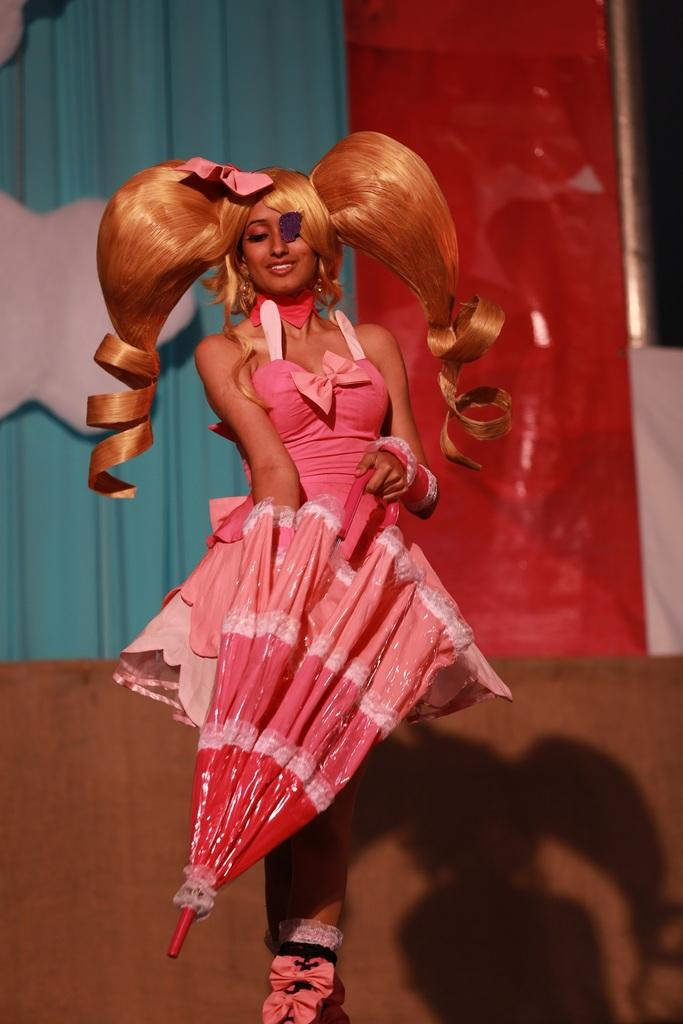Who is present in the image? There is a woman in the image. What is the woman's facial expression? The woman is smiling. What object is the woman holding in the image? The woman is holding an umbrella. What can be seen on the wall in the image? There is a curtain on the wall in the image. What type of skirt is the woman wearing in the image? The image does not show the woman wearing a skirt; she is holding an umbrella. Can you read the letter that the woman is holding in the image? There is no letter present in the image; the woman is holding an umbrella. 